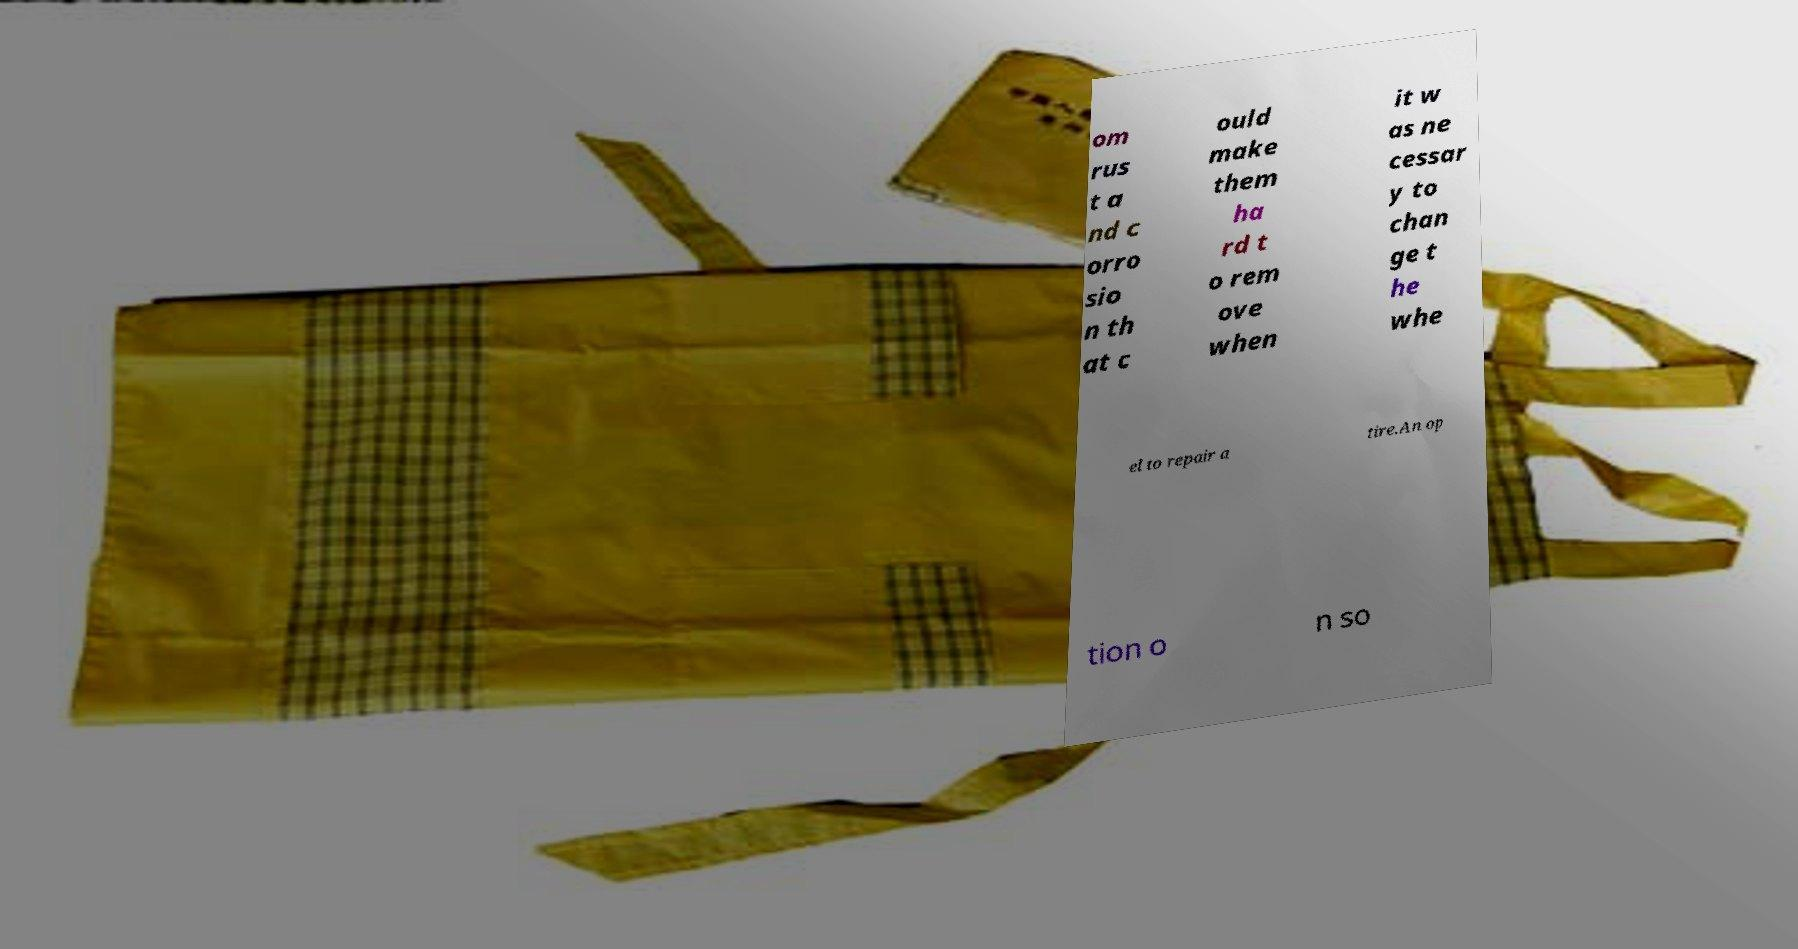There's text embedded in this image that I need extracted. Can you transcribe it verbatim? om rus t a nd c orro sio n th at c ould make them ha rd t o rem ove when it w as ne cessar y to chan ge t he whe el to repair a tire.An op tion o n so 